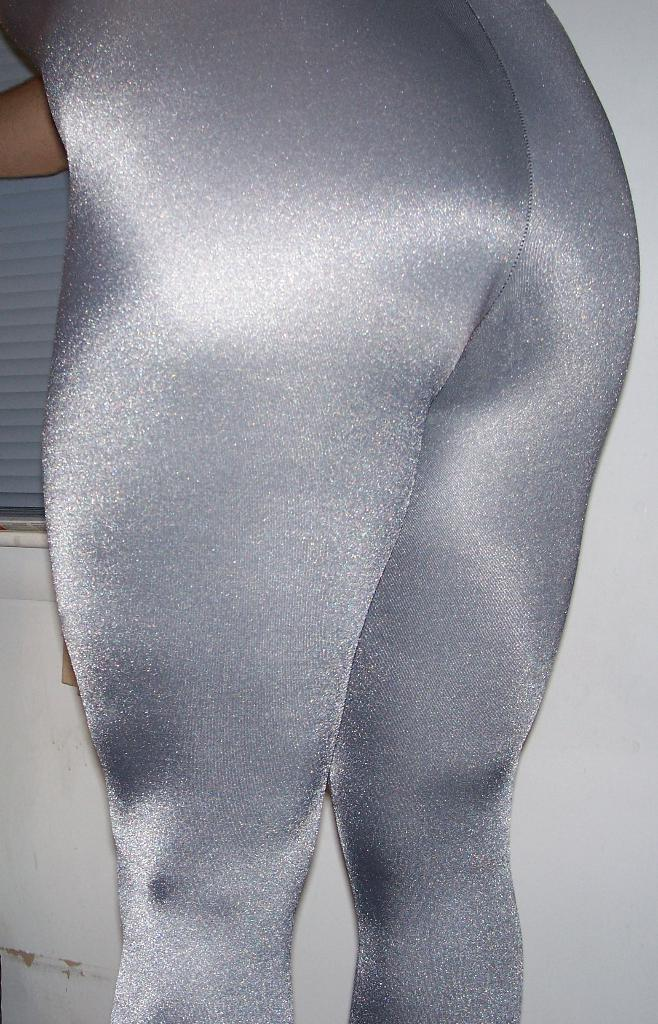Who is the main subject in the image? There is a woman in the image. What is unique about the woman's appearance? The woman is painted grey on her body. Where is the woman located in the image? The woman is standing near a wall. What can be seen on the left side of the image? There is a window blind on the left side of the image. What type of plastic ear can be seen on the woman's body in the image? There is no plastic ear present on the woman's body in the image. What activity is the woman engaged in while standing near the wall? The facts provided do not mention any specific activity the woman is engaged in; she is simply standing near the wall. 